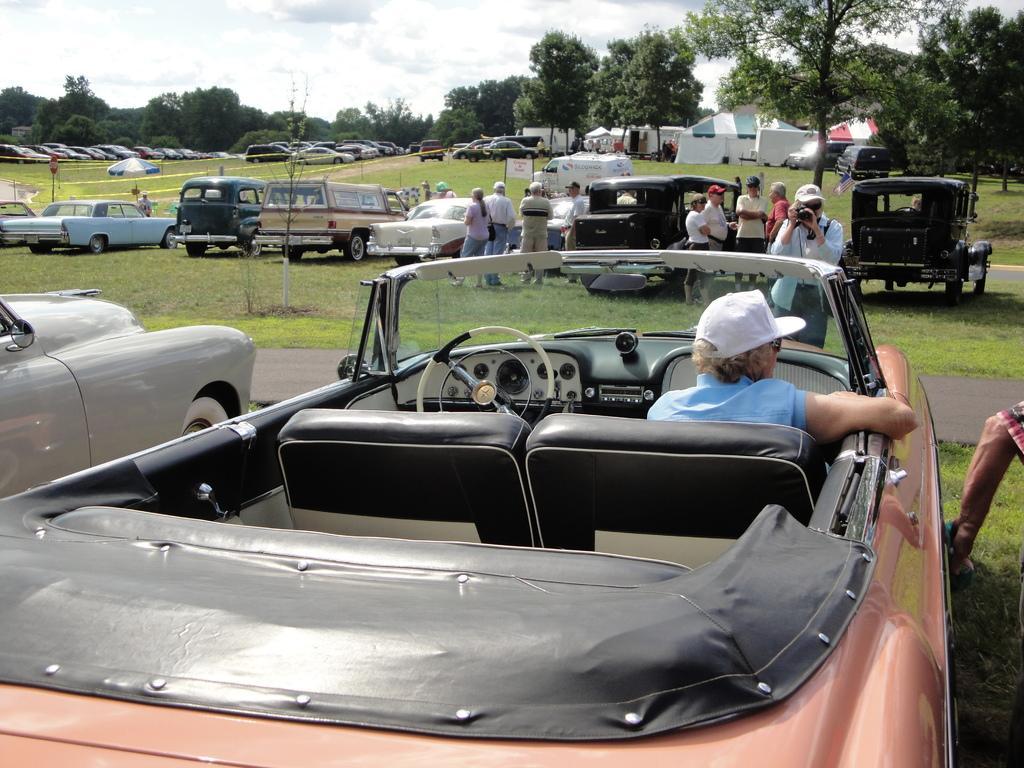Describe this image in one or two sentences. In this picture there are group of people. On the right side of the image there is a person sitting in the car and there is a person standing on the road and holding the camera. At the back there are group of people standing and there are vehicles and there are tents and trees. At the top there is sky and there are clouds. At the bottom there is grass and there is a road. 